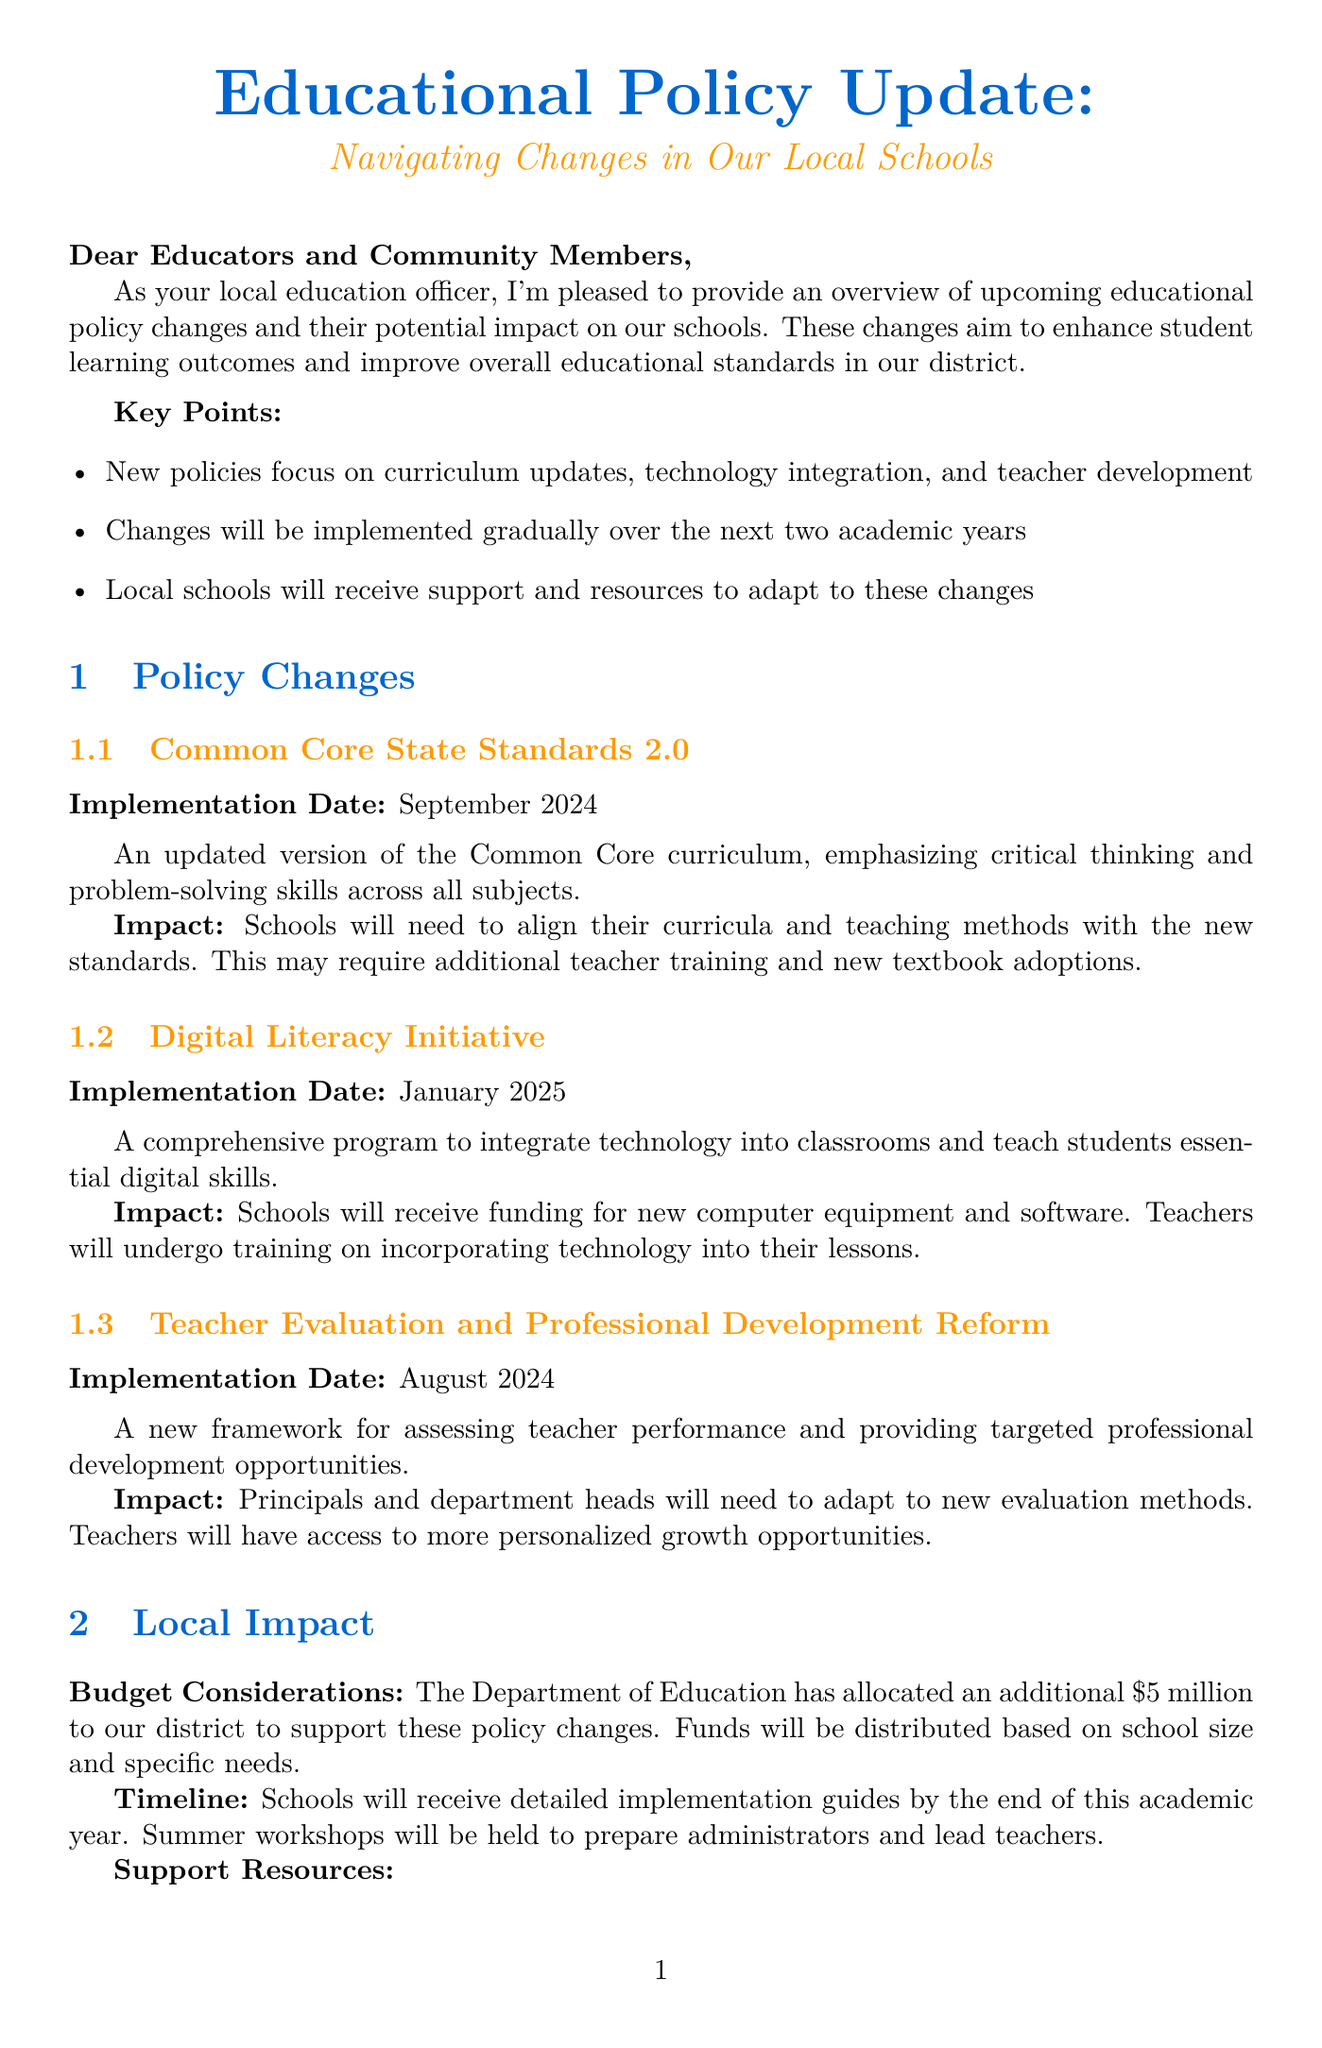What is the title of the newsletter? The title of the newsletter is presented prominently at the top of the document.
Answer: Educational Policy Update: Navigating Changes in Our Local Schools What is the implementation date for the Digital Literacy Initiative? This information is specified under the policy details section in the document.
Answer: January 2025 How much additional funding has been allocated to the district for these policy changes? The budget considerations section states the allocated amount explicitly.
Answer: $5 million Which framework will provide targeted professional development opportunities for teachers? The specific framework is outlined clearly within the policy changes section.
Answer: Teacher Evaluation and Professional Development Reform What will schools receive to help with the policy changes? This detail is mentioned in the local impact section, referring to the resources for schools.
Answer: Support and resources When will town hall meetings be held? The timing is inferred from the stakeholder engagement section emphasizing parent involvement.
Answer: In each school zone What kind of skills will the Digital Literacy Initiative focus on teaching students? This information is provided in the description of the Digital Literacy Initiative.
Answer: Essential digital skills Who should be contacted for policy-related queries? The conclusion section provides the contact information for assistance with queries.
Answer: 1-800-555-EDU 